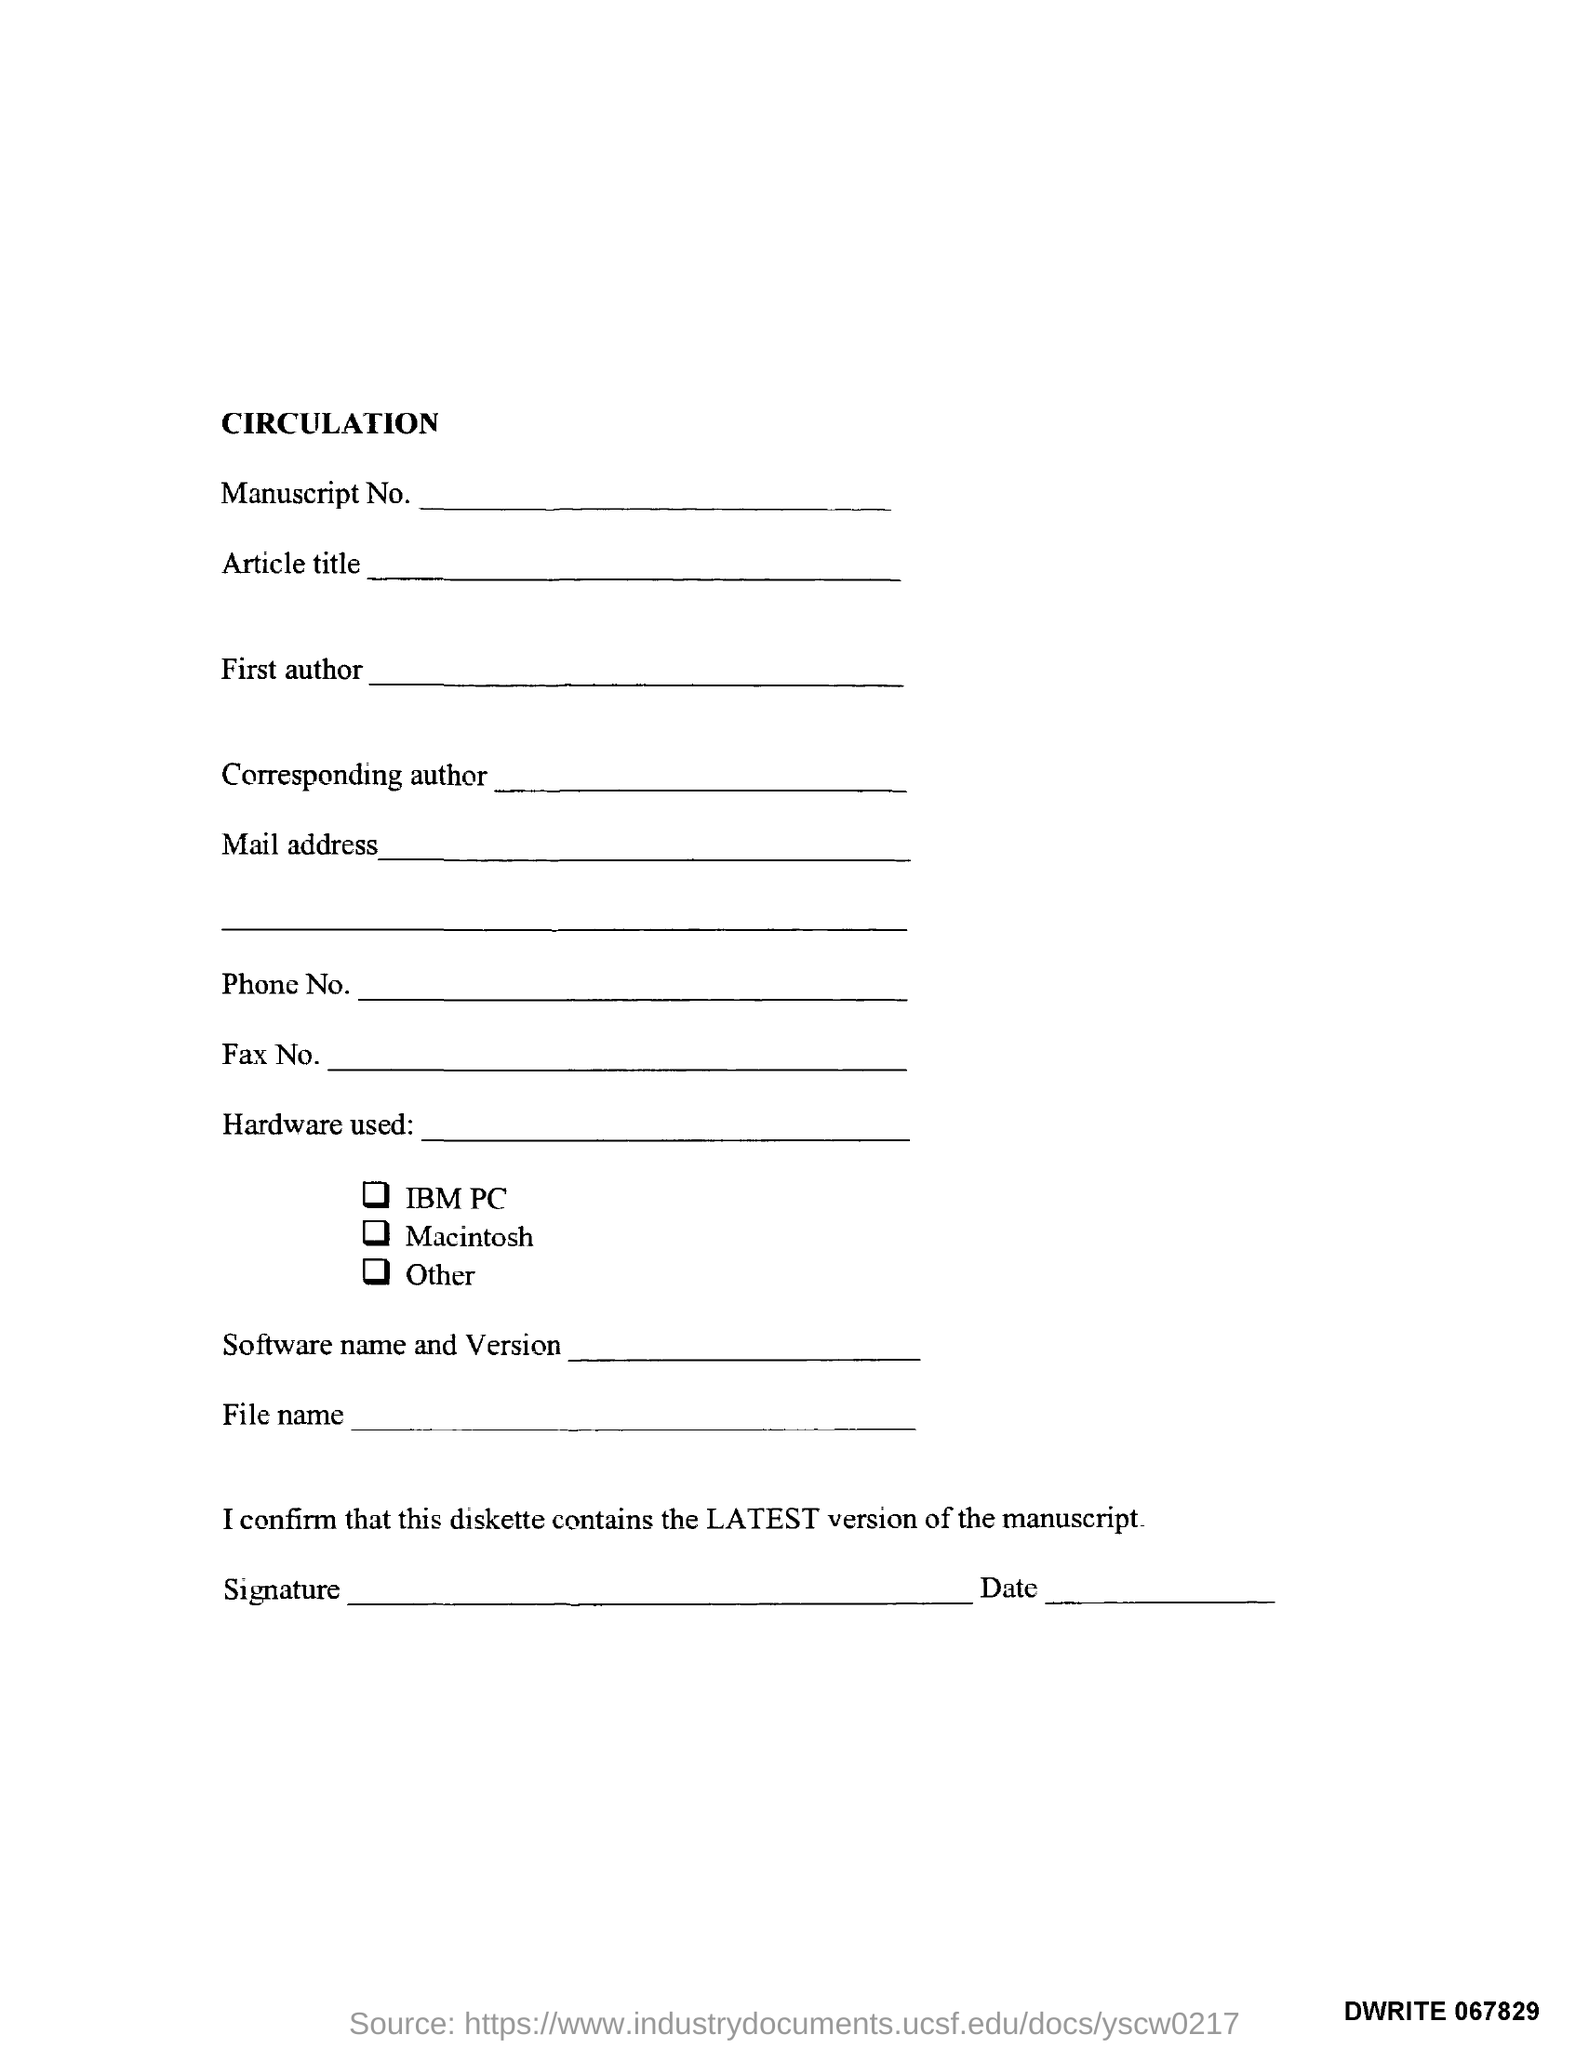What is the Title of the document?
Make the answer very short. Circulation. What is the Document Number?
Make the answer very short. DWrite 067829. 